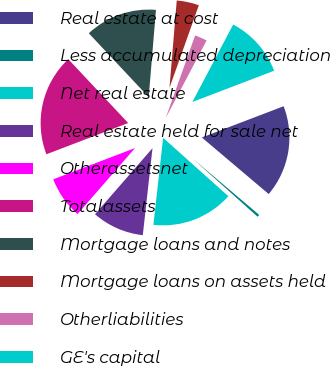Convert chart. <chart><loc_0><loc_0><loc_500><loc_500><pie_chart><fcel>Real estate at cost<fcel>Less accumulated depreciation<fcel>Net real estate<fcel>Real estate held for sale net<fcel>Otherassetsnet<fcel>Totalassets<fcel>Mortgage loans and notes<fcel>Mortgage loans on assets held<fcel>Otherliabilities<fcel>GE's capital<nl><fcel>16.99%<fcel>0.44%<fcel>15.15%<fcel>9.63%<fcel>7.79%<fcel>18.82%<fcel>13.31%<fcel>4.12%<fcel>2.28%<fcel>11.47%<nl></chart> 